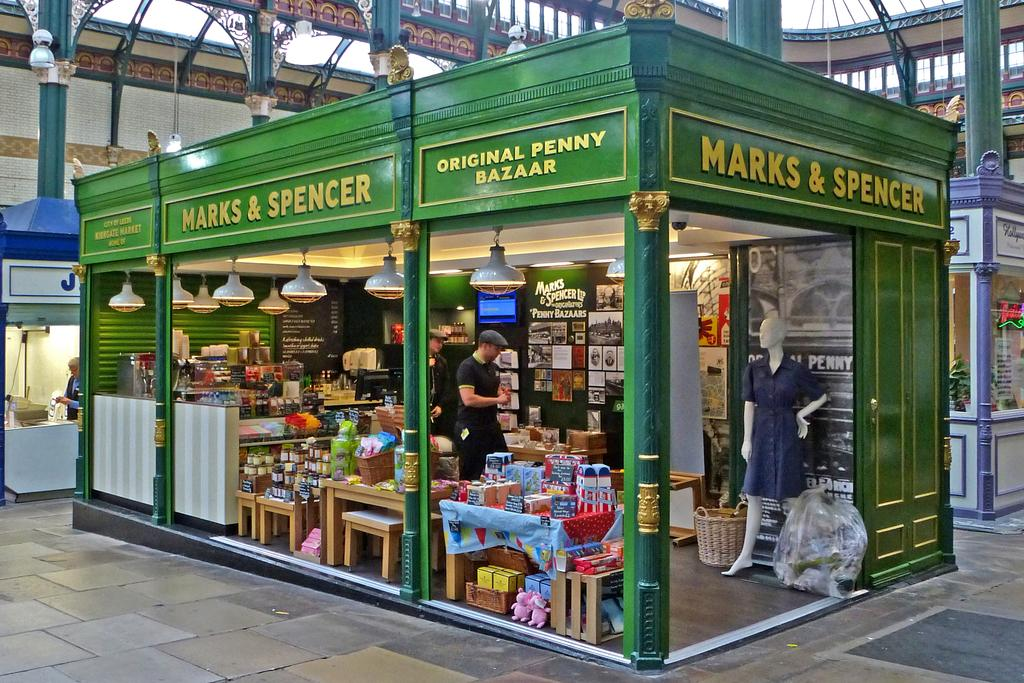<image>
Present a compact description of the photo's key features. A small old fashioned looking Marks and Spencer 